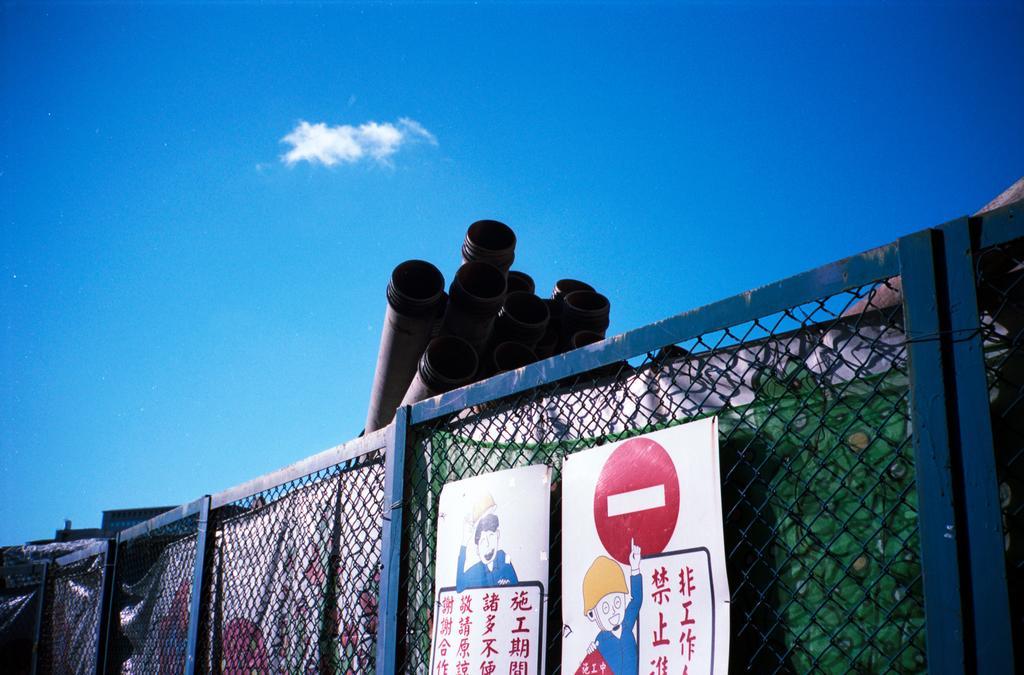How would you summarize this image in a sentence or two? In the image there is a mesh and there are two posters attached in front of the mesh. Behind the mesh there are some pipes. 